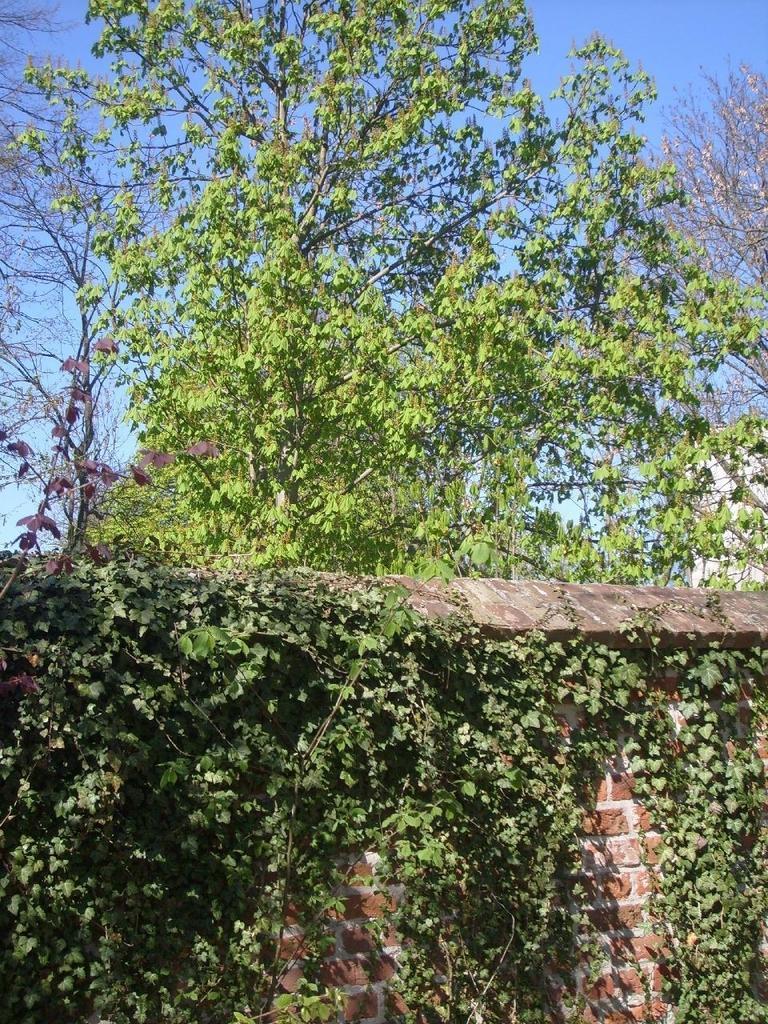Can you describe this image briefly? In this image I can see the wall, few plants in green color and the sky is in blue color. 